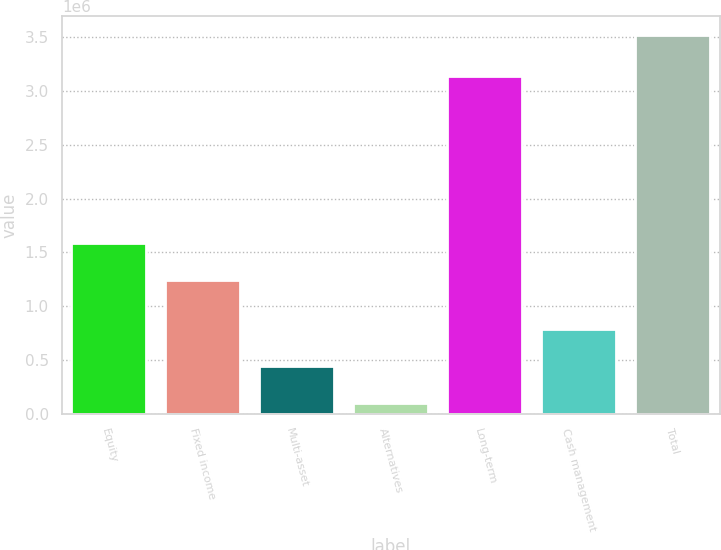<chart> <loc_0><loc_0><loc_500><loc_500><bar_chart><fcel>Equity<fcel>Fixed income<fcel>Multi-asset<fcel>Alternatives<fcel>Long-term<fcel>Cash management<fcel>Total<nl><fcel>1.5885e+06<fcel>1.24772e+06<fcel>445721<fcel>104948<fcel>3.13795e+06<fcel>786495<fcel>3.51268e+06<nl></chart> 